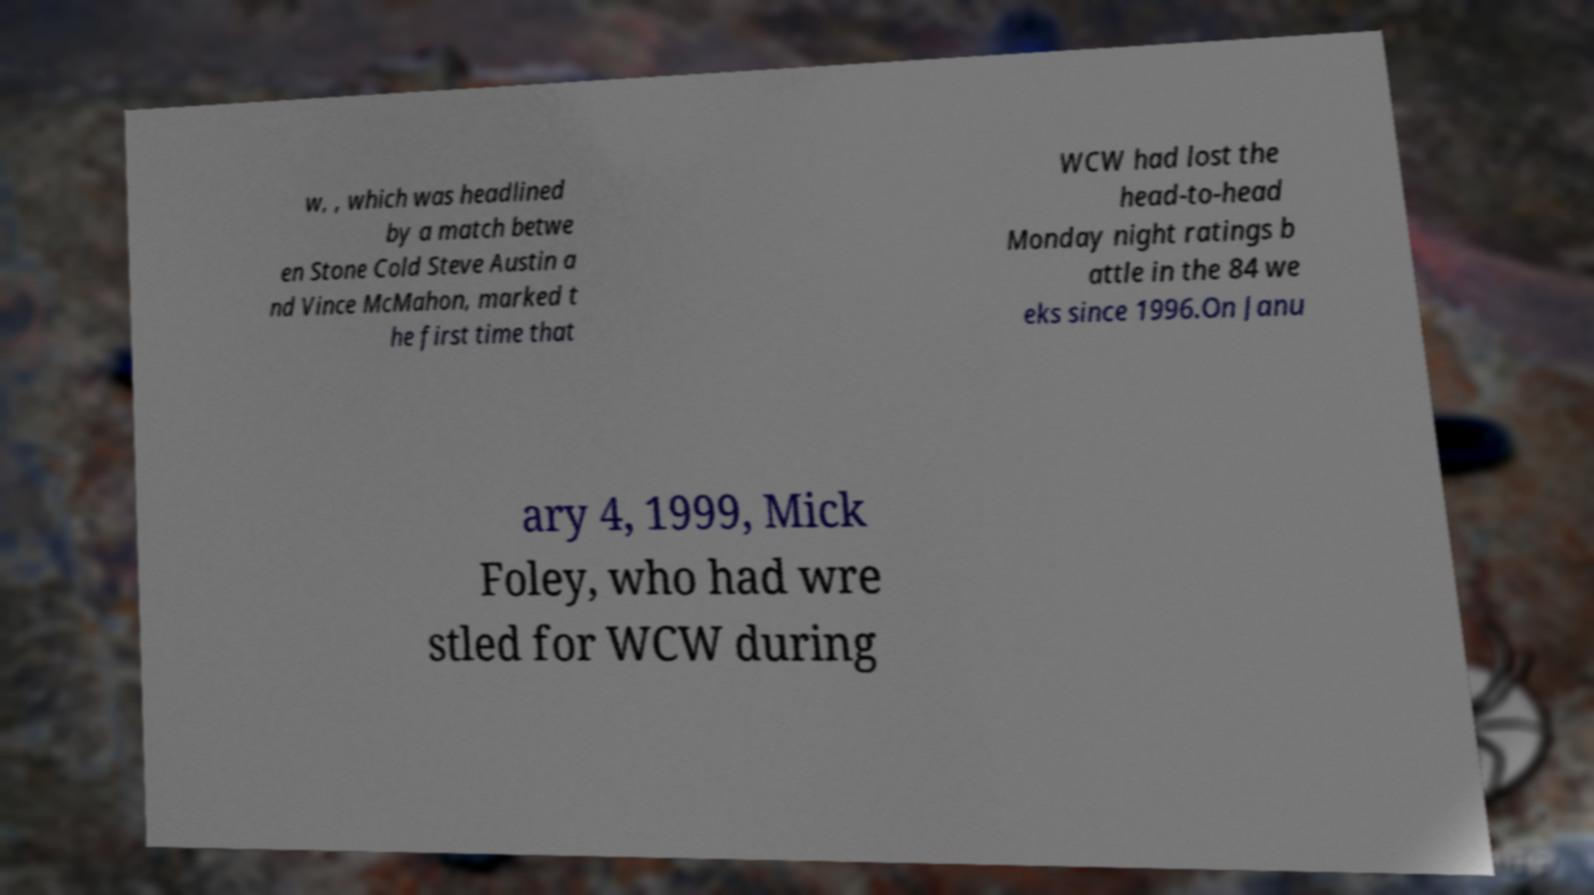What messages or text are displayed in this image? I need them in a readable, typed format. w, , which was headlined by a match betwe en Stone Cold Steve Austin a nd Vince McMahon, marked t he first time that WCW had lost the head-to-head Monday night ratings b attle in the 84 we eks since 1996.On Janu ary 4, 1999, Mick Foley, who had wre stled for WCW during 